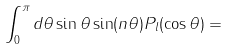<formula> <loc_0><loc_0><loc_500><loc_500>\int _ { 0 } ^ { \pi } d \theta \sin \theta \sin ( n \theta ) P _ { l } ( \cos \theta ) =</formula> 